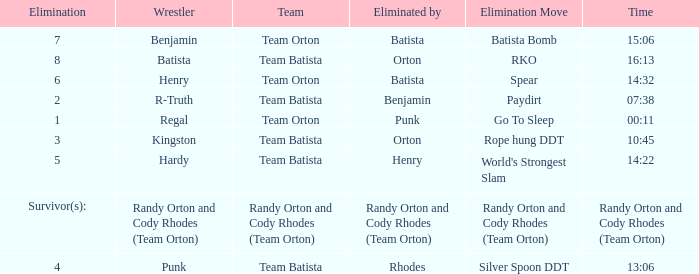Parse the full table. {'header': ['Elimination', 'Wrestler', 'Team', 'Eliminated by', 'Elimination Move', 'Time'], 'rows': [['7', 'Benjamin', 'Team Orton', 'Batista', 'Batista Bomb', '15:06'], ['8', 'Batista', 'Team Batista', 'Orton', 'RKO', '16:13'], ['6', 'Henry', 'Team Orton', 'Batista', 'Spear', '14:32'], ['2', 'R-Truth', 'Team Batista', 'Benjamin', 'Paydirt', '07:38'], ['1', 'Regal', 'Team Orton', 'Punk', 'Go To Sleep', '00:11'], ['3', 'Kingston', 'Team Batista', 'Orton', 'Rope hung DDT', '10:45'], ['5', 'Hardy', 'Team Batista', 'Henry', "World's Strongest Slam", '14:22'], ['Survivor(s):', 'Randy Orton and Cody Rhodes (Team Orton)', 'Randy Orton and Cody Rhodes (Team Orton)', 'Randy Orton and Cody Rhodes (Team Orton)', 'Randy Orton and Cody Rhodes (Team Orton)', 'Randy Orton and Cody Rhodes (Team Orton)'], ['4', 'Punk', 'Team Batista', 'Rhodes', 'Silver Spoon DDT', '13:06']]} What time was the Wrestler Henry eliminated by Batista? 14:32. 